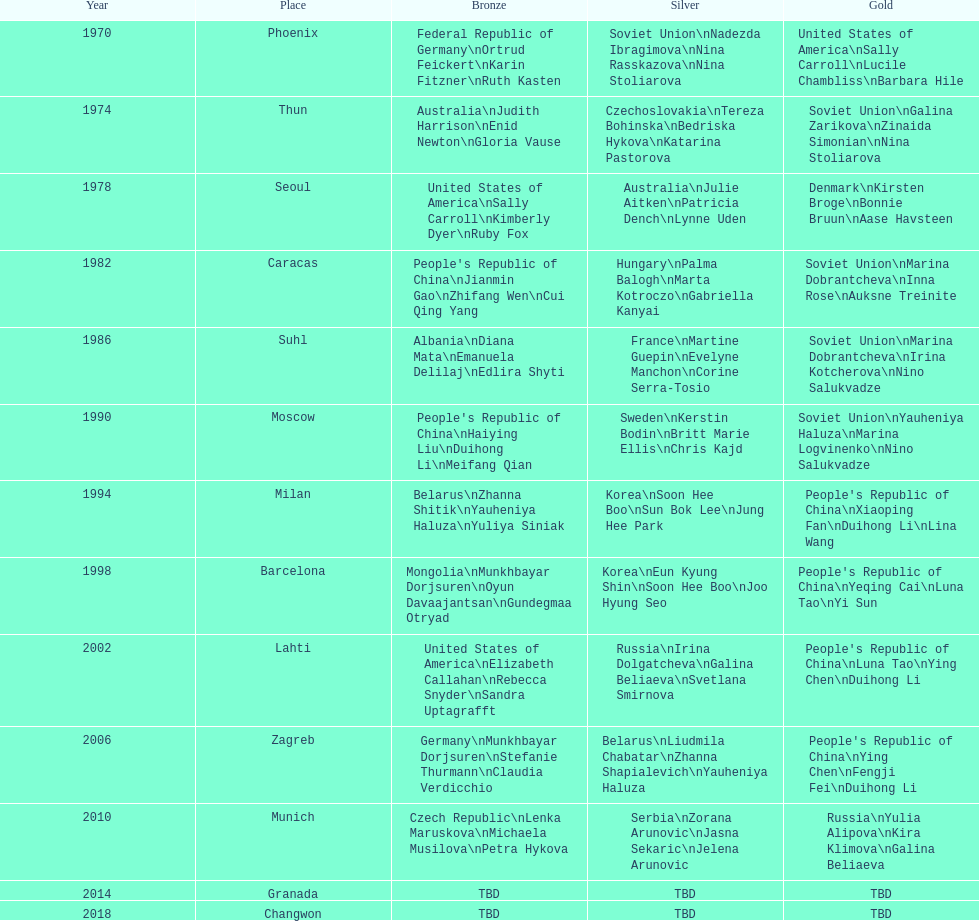Which country is listed the most under the silver column? Korea. 